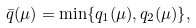Convert formula to latex. <formula><loc_0><loc_0><loc_500><loc_500>\bar { q } ( \mu ) = \min \{ q _ { 1 } ( \mu ) , q _ { 2 } ( \mu ) \} ,</formula> 